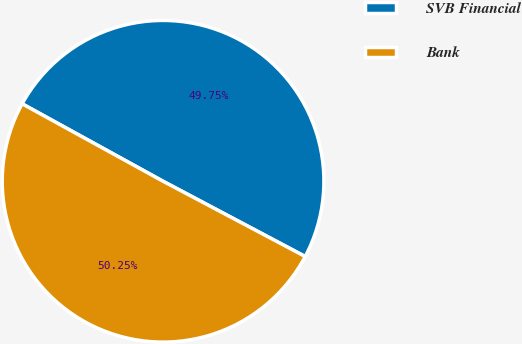<chart> <loc_0><loc_0><loc_500><loc_500><pie_chart><fcel>SVB Financial<fcel>Bank<nl><fcel>49.75%<fcel>50.25%<nl></chart> 